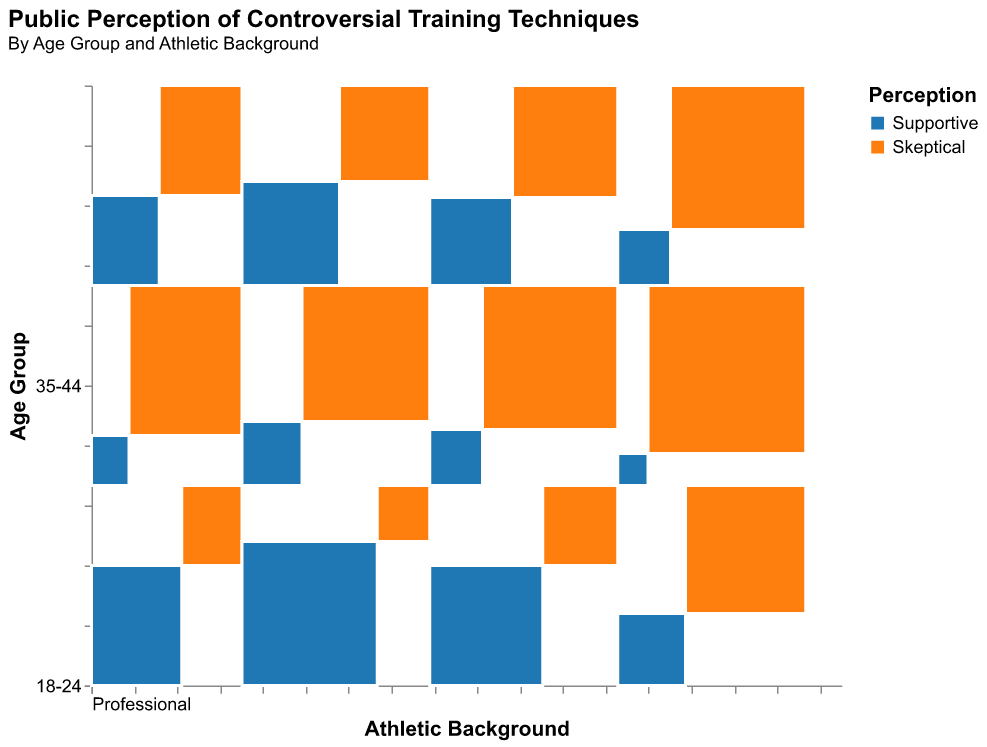What is the title of the plot? The title is located at the top of the plot and gives a summary of what the plot is about.
Answer: Public Perception of Controversial Training Techniques Which age group has the highest overall count of supportive perceptions? By observing the rectangles colored in blue, which represent supportive perceptions, we identify the largest rectangles vertically among age groups. The age group 25-34 has the highest overall count of supportive perceptions.
Answer: 25-34 How do the perceptions of professional athletes in the 45+ age group compare between supportive and skeptical? Look at the 45+ age group and locate the segments specific to professional athletes. Count the segments for both supportive (blue) and skeptical (orange). There are 90 counts of supportive and 160 counts of skeptical professionals.
Answer: Skeptical is higher Which athletic background has a larger proportion of skeptical perceptions in the 35-44 age group? Observe the sections for the 35-44 age group and compare the orange portions of each athletic background segment. The largest orange portion belongs to non-athletes.
Answer: Non-athlete What is the total number of non-athletes across all age groups? Sum up the counts of non-athlete segments for each age group. The counts are: 50 + 150 + 80 + 170 + 70 + 180 + 40 + 210 = 950.
Answer: 950 Compare the number of supportive perceptions among amateurs and professionals in the 25-34 age group. Locate the supportive (blue) segments within the 25-34 age group for both amateurs and professionals and compare their counts. Professionals: 180, Amateurs: 130.
Answer: Professionals have more Which age group shows the highest discrepancy between supportive and skeptical perceptions within amateur athletes? Calculate the difference between supportive and skeptical perceptions for amateur athletes in each age group. The discrepancies are: 18-24: 90 - 110 = -20, 25-34: 130 - 120 = 10, 35-44: 110 - 140 = -30, 45+: 70 - 180 = -110. The highest discrepancy is in the 45+ age group.
Answer: 45+ Are skeptical perceptions more common among non-athletes or amateur athletes in the 18-24 age group? Compare the count of skeptical perceptions between non-athletes and amateur athletes in the 18-24 age group. Non-athletes: 150, Amateurs: 110.
Answer: Non-athletes What is the trend of supportive perceptions across age groups for professional athletes? Observe the blue sections for professional athletes as you move from 18-24 to 45+. The counts are: 120, 180, 150, 90, indicating a decreasing trend after the initial increase.
Answer: Decreasing trend after 25-34 How many supportive perceptions are there among non-athletes in the age group 35-44? Locate the supportive (blue) segment for non-athletes in the 35-44 age group and note the count.
Answer: 70 